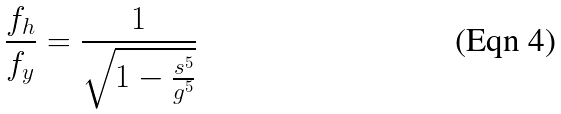Convert formula to latex. <formula><loc_0><loc_0><loc_500><loc_500>\frac { f _ { h } } { f _ { y } } = \frac { 1 } { \sqrt { 1 - \frac { s ^ { 5 } } { g ^ { 5 } } } }</formula> 